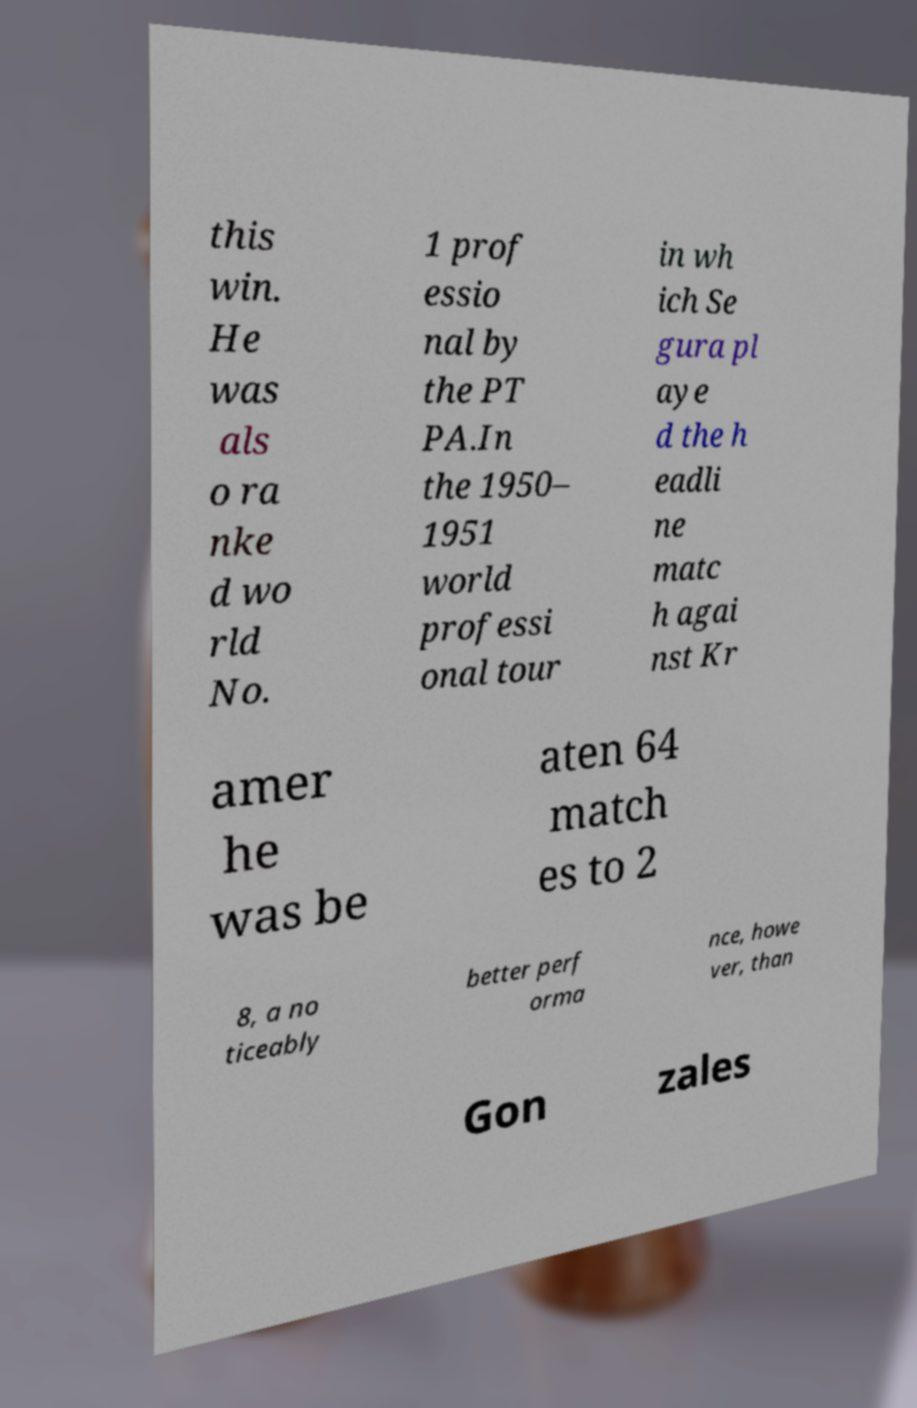Could you assist in decoding the text presented in this image and type it out clearly? this win. He was als o ra nke d wo rld No. 1 prof essio nal by the PT PA.In the 1950– 1951 world professi onal tour in wh ich Se gura pl aye d the h eadli ne matc h agai nst Kr amer he was be aten 64 match es to 2 8, a no ticeably better perf orma nce, howe ver, than Gon zales 